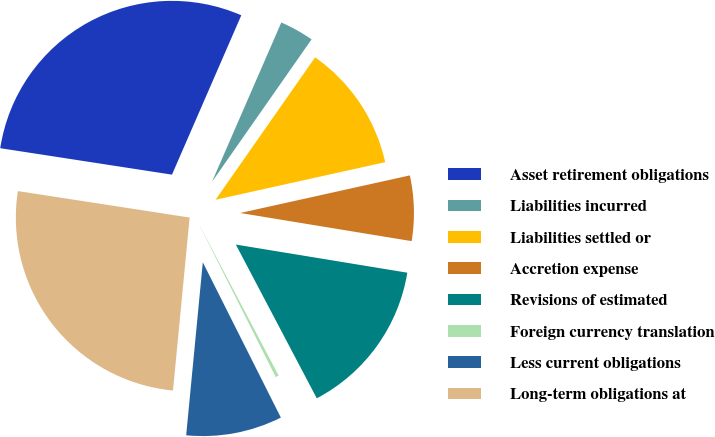Convert chart to OTSL. <chart><loc_0><loc_0><loc_500><loc_500><pie_chart><fcel>Asset retirement obligations<fcel>Liabilities incurred<fcel>Liabilities settled or<fcel>Accretion expense<fcel>Revisions of estimated<fcel>Foreign currency translation<fcel>Less current obligations<fcel>Long-term obligations at<nl><fcel>29.1%<fcel>3.18%<fcel>11.82%<fcel>6.06%<fcel>14.7%<fcel>0.3%<fcel>8.94%<fcel>25.91%<nl></chart> 